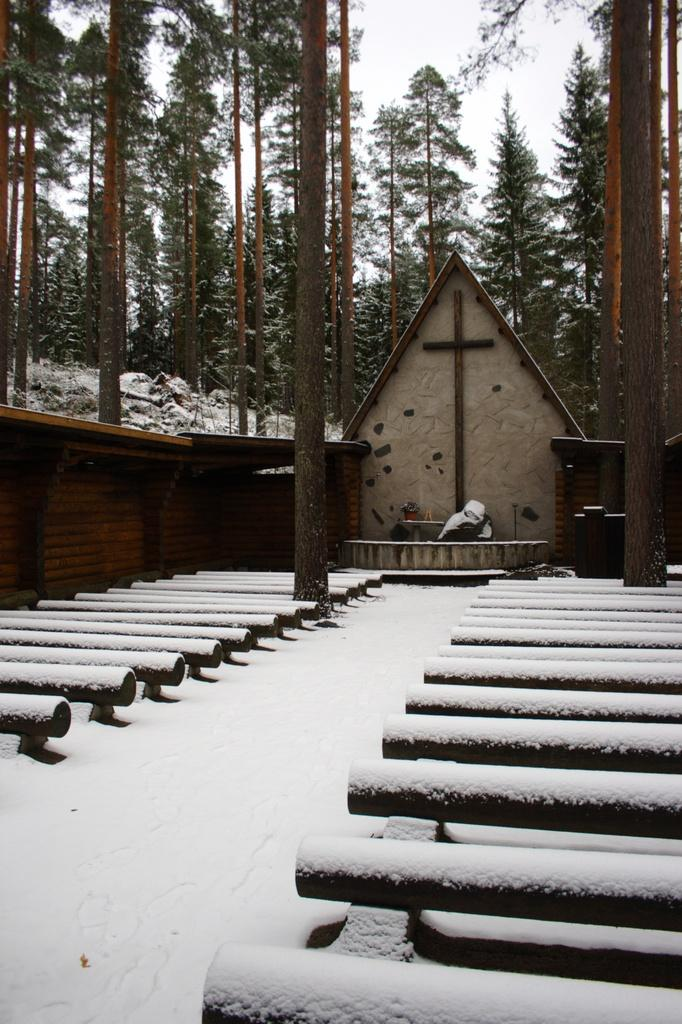What is the main structure in the center of the image? There is a house in the center of the image. What type of seating can be seen in the image? There are benches in the image. What are the tall, vertical objects in the image? There are poles in the image. What type of vegetation is visible in the background? There are trees in the background of the image. What type of weather condition is depicted in the image? There is snow at the bottom of the image, indicating a snowy condition. What religious symbol is present in the center of the image? There is a cross in the center of the image. What type of cushion is placed on the cross in the image? There is no cushion present on the cross in the image. Who is wearing the crown in the image? There is no crown or person wearing a crown present in the image. 